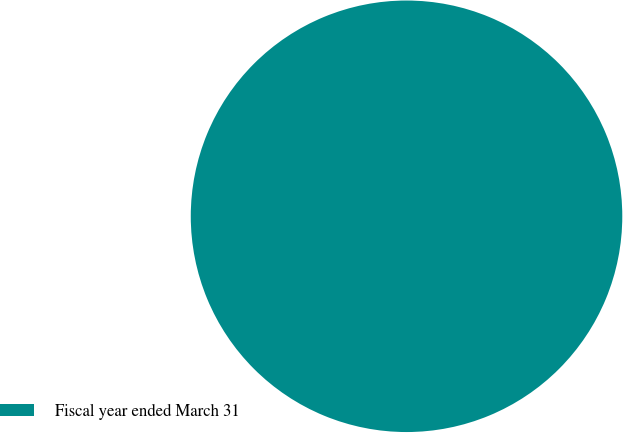Convert chart. <chart><loc_0><loc_0><loc_500><loc_500><pie_chart><fcel>Fiscal year ended March 31<nl><fcel>100.0%<nl></chart> 